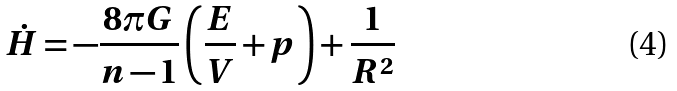Convert formula to latex. <formula><loc_0><loc_0><loc_500><loc_500>\dot { H } = - \frac { 8 \pi G } { n - 1 } \left ( \frac { E } { V } + p \right ) + \frac { 1 } { R ^ { 2 } }</formula> 